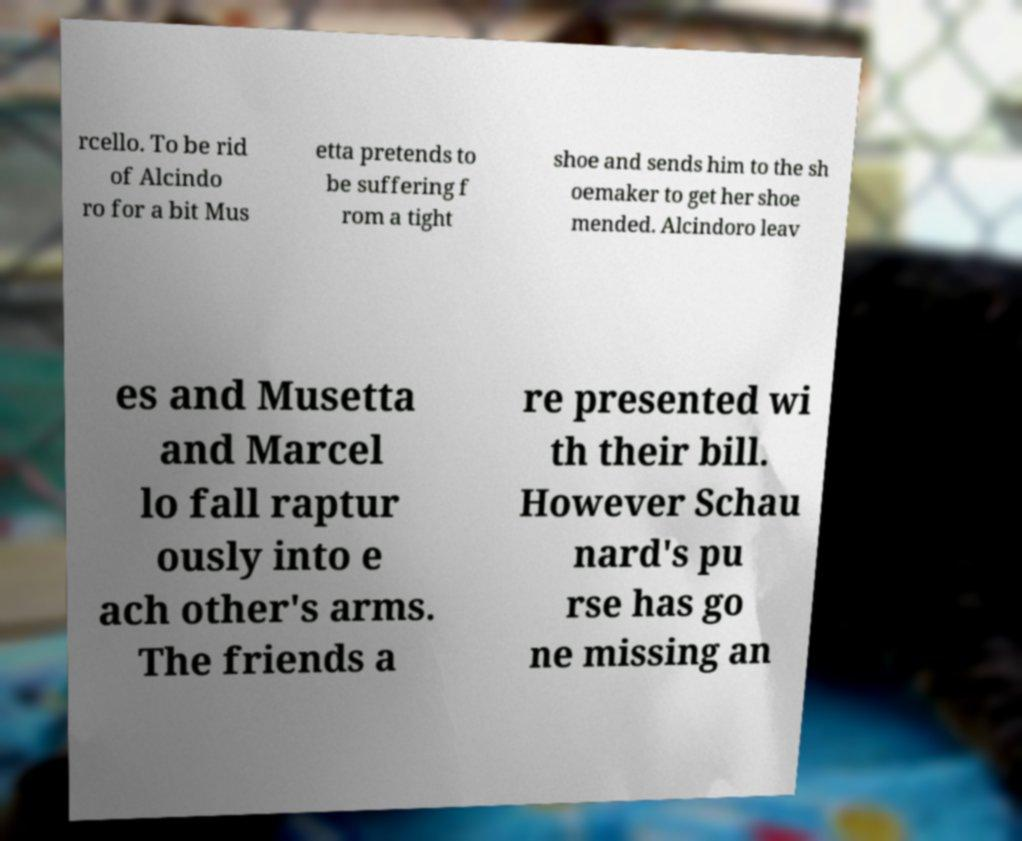Please read and relay the text visible in this image. What does it say? rcello. To be rid of Alcindo ro for a bit Mus etta pretends to be suffering f rom a tight shoe and sends him to the sh oemaker to get her shoe mended. Alcindoro leav es and Musetta and Marcel lo fall raptur ously into e ach other's arms. The friends a re presented wi th their bill. However Schau nard's pu rse has go ne missing an 